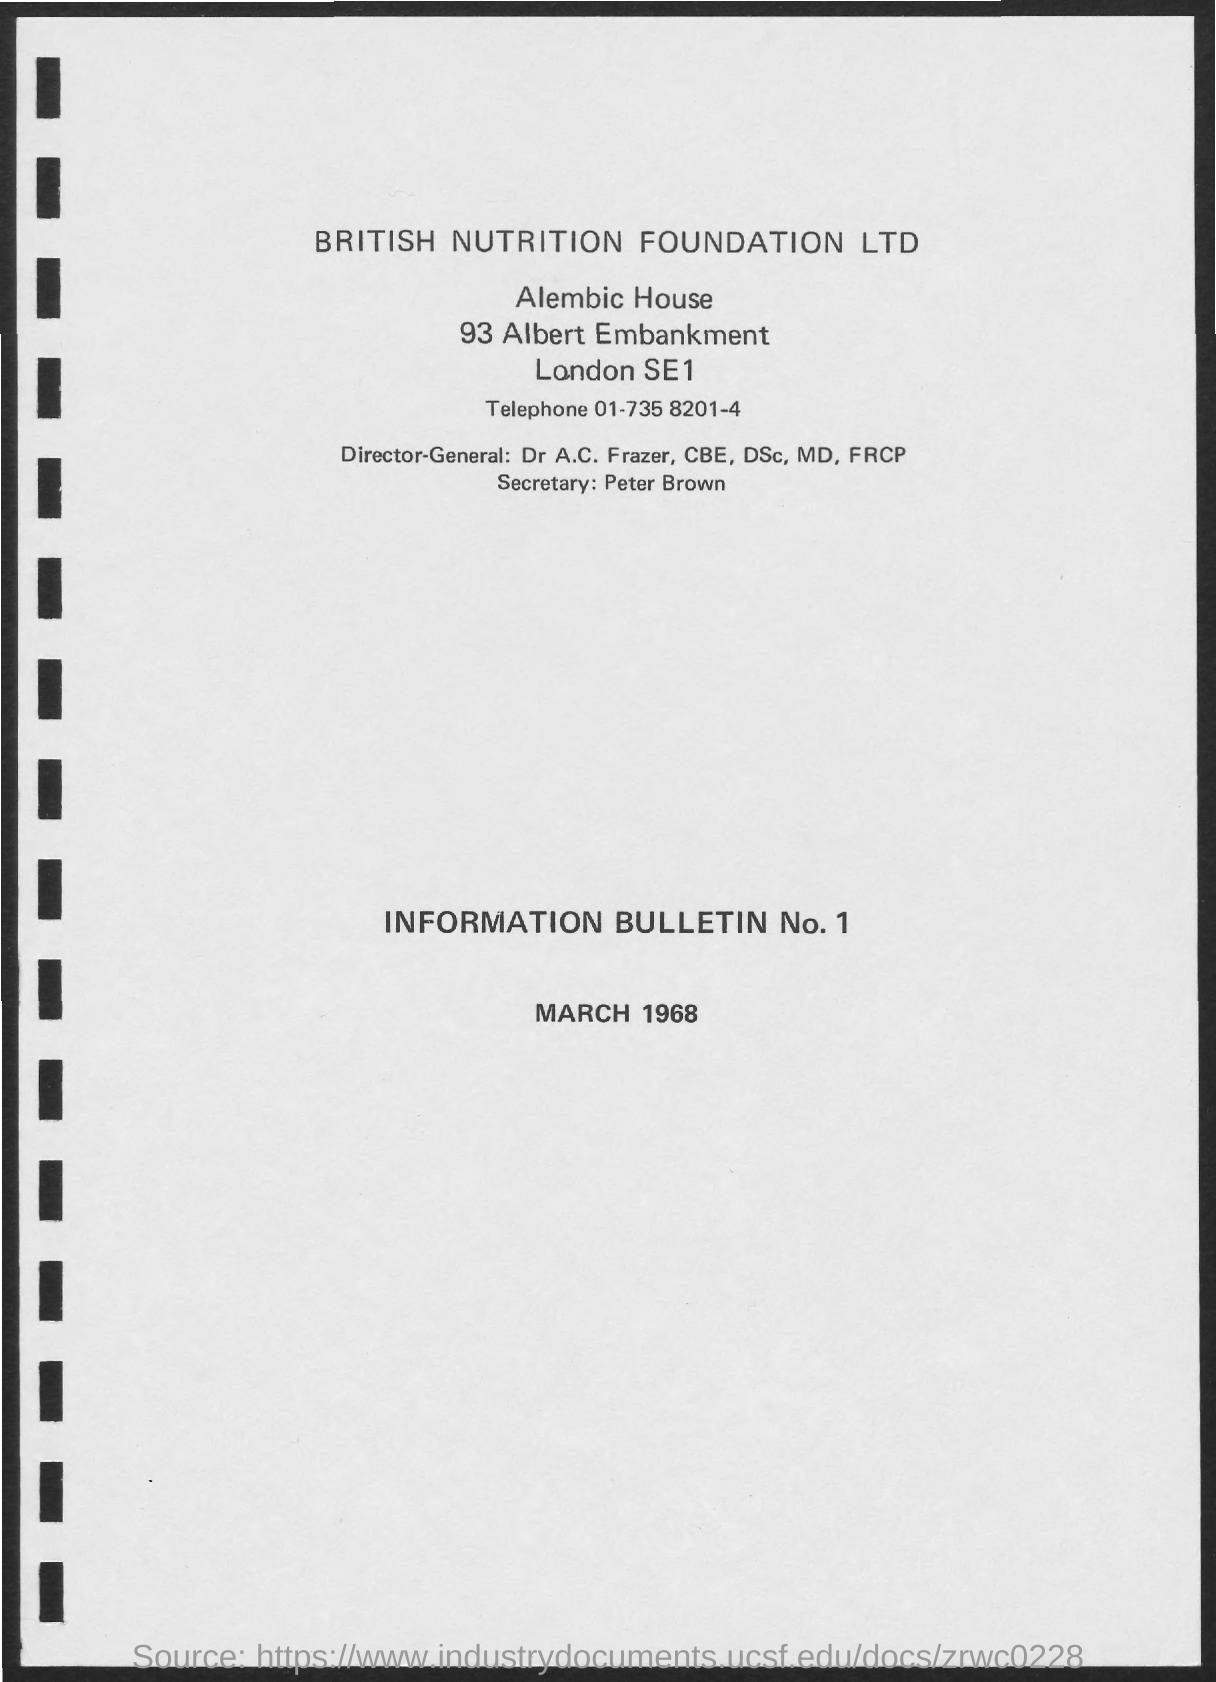Who is the Director-General of British Nutrition Foundation Ltd?
Keep it short and to the point. Dr A.C. Frazer, CBE, Dsc, MD, FRCP. Who is the Secretary of British Nutrition Foundation Ltd?
Your answer should be compact. Peter Brown. 